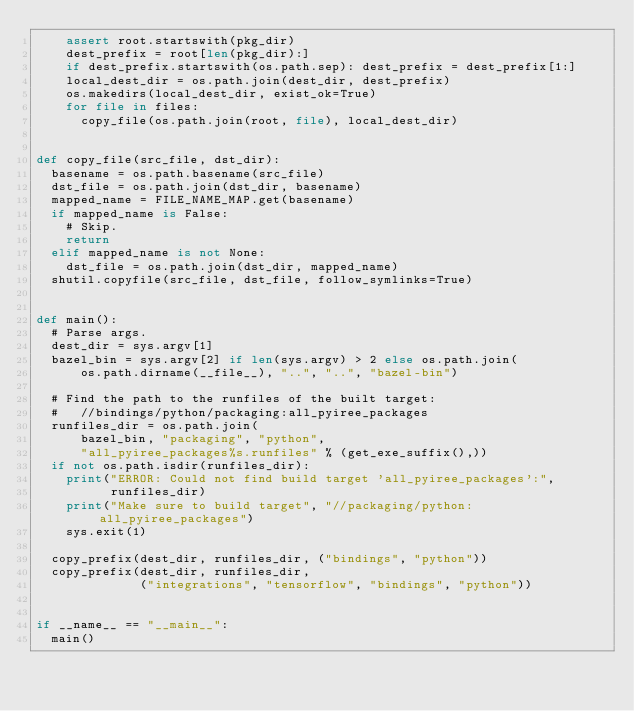<code> <loc_0><loc_0><loc_500><loc_500><_Python_>    assert root.startswith(pkg_dir)
    dest_prefix = root[len(pkg_dir):]
    if dest_prefix.startswith(os.path.sep): dest_prefix = dest_prefix[1:]
    local_dest_dir = os.path.join(dest_dir, dest_prefix)
    os.makedirs(local_dest_dir, exist_ok=True)
    for file in files:
      copy_file(os.path.join(root, file), local_dest_dir)


def copy_file(src_file, dst_dir):
  basename = os.path.basename(src_file)
  dst_file = os.path.join(dst_dir, basename)
  mapped_name = FILE_NAME_MAP.get(basename)
  if mapped_name is False:
    # Skip.
    return
  elif mapped_name is not None:
    dst_file = os.path.join(dst_dir, mapped_name)
  shutil.copyfile(src_file, dst_file, follow_symlinks=True)


def main():
  # Parse args.
  dest_dir = sys.argv[1]
  bazel_bin = sys.argv[2] if len(sys.argv) > 2 else os.path.join(
      os.path.dirname(__file__), "..", "..", "bazel-bin")

  # Find the path to the runfiles of the built target:
  #   //bindings/python/packaging:all_pyiree_packages
  runfiles_dir = os.path.join(
      bazel_bin, "packaging", "python",
      "all_pyiree_packages%s.runfiles" % (get_exe_suffix(),))
  if not os.path.isdir(runfiles_dir):
    print("ERROR: Could not find build target 'all_pyiree_packages':",
          runfiles_dir)
    print("Make sure to build target", "//packaging/python:all_pyiree_packages")
    sys.exit(1)

  copy_prefix(dest_dir, runfiles_dir, ("bindings", "python"))
  copy_prefix(dest_dir, runfiles_dir,
              ("integrations", "tensorflow", "bindings", "python"))


if __name__ == "__main__":
  main()
</code> 